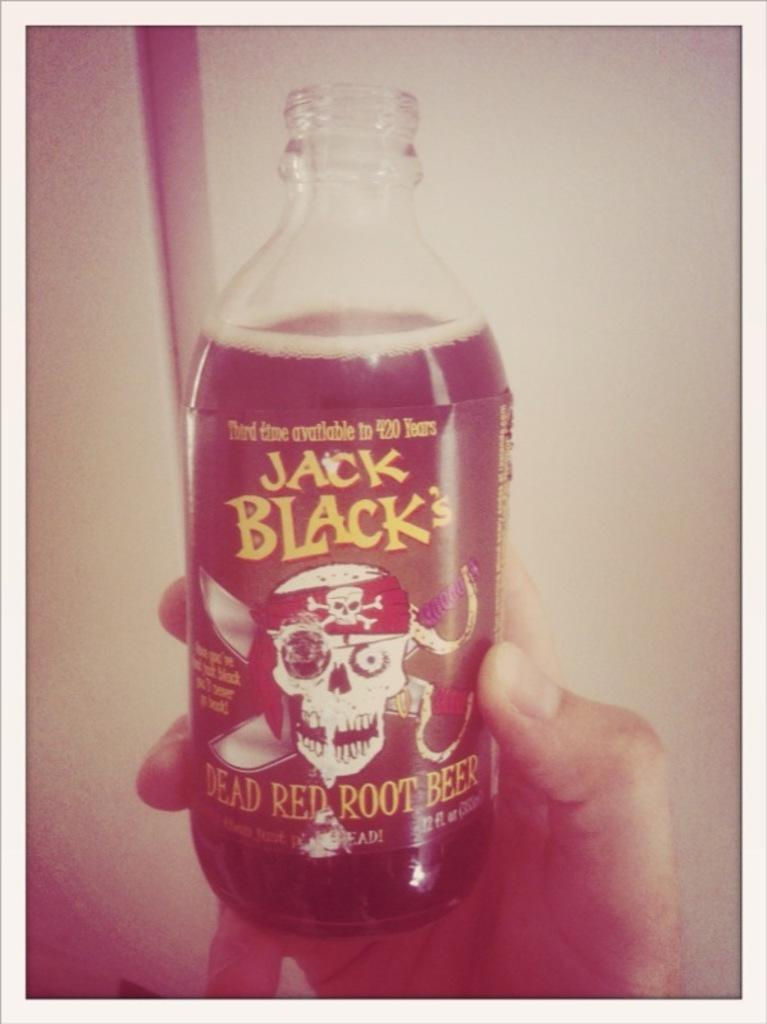<image>
Create a compact narrative representing the image presented. A hand is holding up a bottle of Jack Black's Root Beer. 